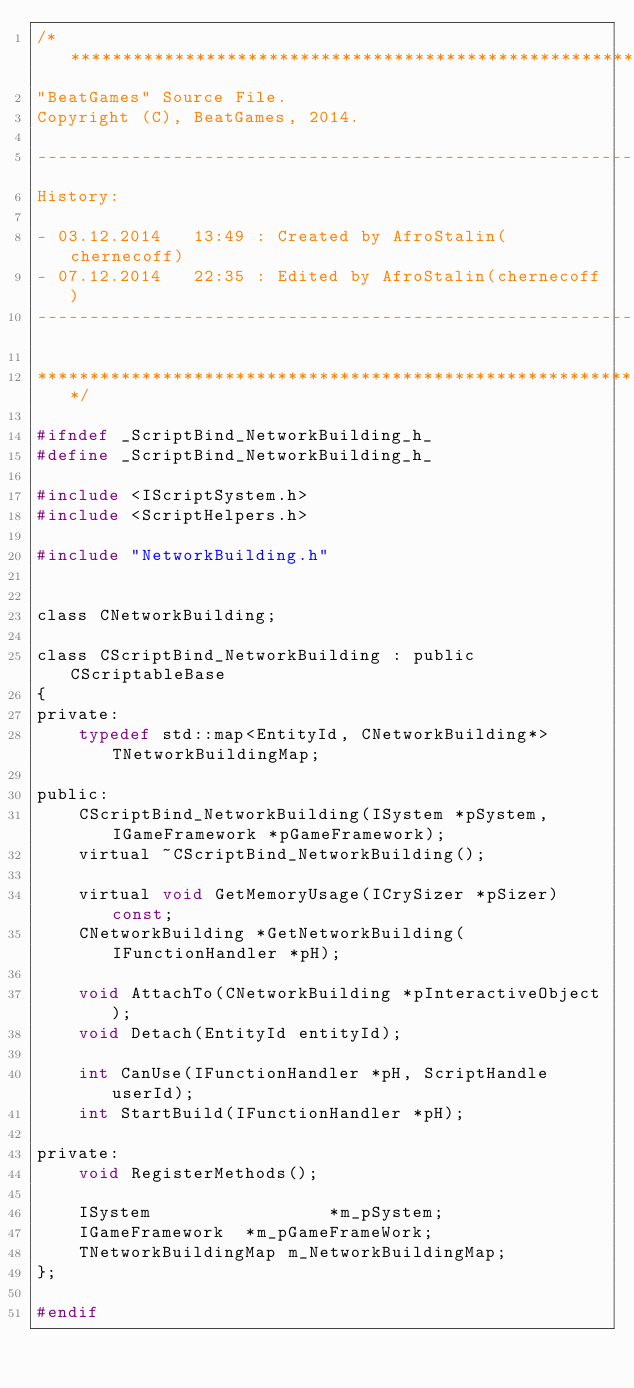Convert code to text. <code><loc_0><loc_0><loc_500><loc_500><_C_>/*************************************************************************
"BeatGames" Source File.
Copyright (C), BeatGames, 2014.

-------------------------------------------------------------------------
History:

- 03.12.2014   13:49 : Created by AfroStalin(chernecoff)
- 07.12.2014   22:35 : Edited by AfroStalin(chernecoff)
-------------------------------------------------------------------------

*************************************************************************/

#ifndef _ScriptBind_NetworkBuilding_h_
#define _ScriptBind_NetworkBuilding_h_

#include <IScriptSystem.h>
#include <ScriptHelpers.h>

#include "NetworkBuilding.h"


class CNetworkBuilding;

class CScriptBind_NetworkBuilding : public CScriptableBase
{
private:
	typedef std::map<EntityId, CNetworkBuilding*> TNetworkBuildingMap;

public:
	CScriptBind_NetworkBuilding(ISystem *pSystem, IGameFramework *pGameFramework);
	virtual ~CScriptBind_NetworkBuilding();

	virtual void GetMemoryUsage(ICrySizer *pSizer) const;
	CNetworkBuilding *GetNetworkBuilding(IFunctionHandler *pH);

	void AttachTo(CNetworkBuilding *pInteractiveObject);
	void Detach(EntityId entityId);

	int CanUse(IFunctionHandler *pH, ScriptHandle userId);
	int StartBuild(IFunctionHandler *pH);

private:
	void RegisterMethods();

	ISystem					*m_pSystem;
	IGameFramework	*m_pGameFrameWork;
	TNetworkBuildingMap m_NetworkBuildingMap;
};

#endif</code> 